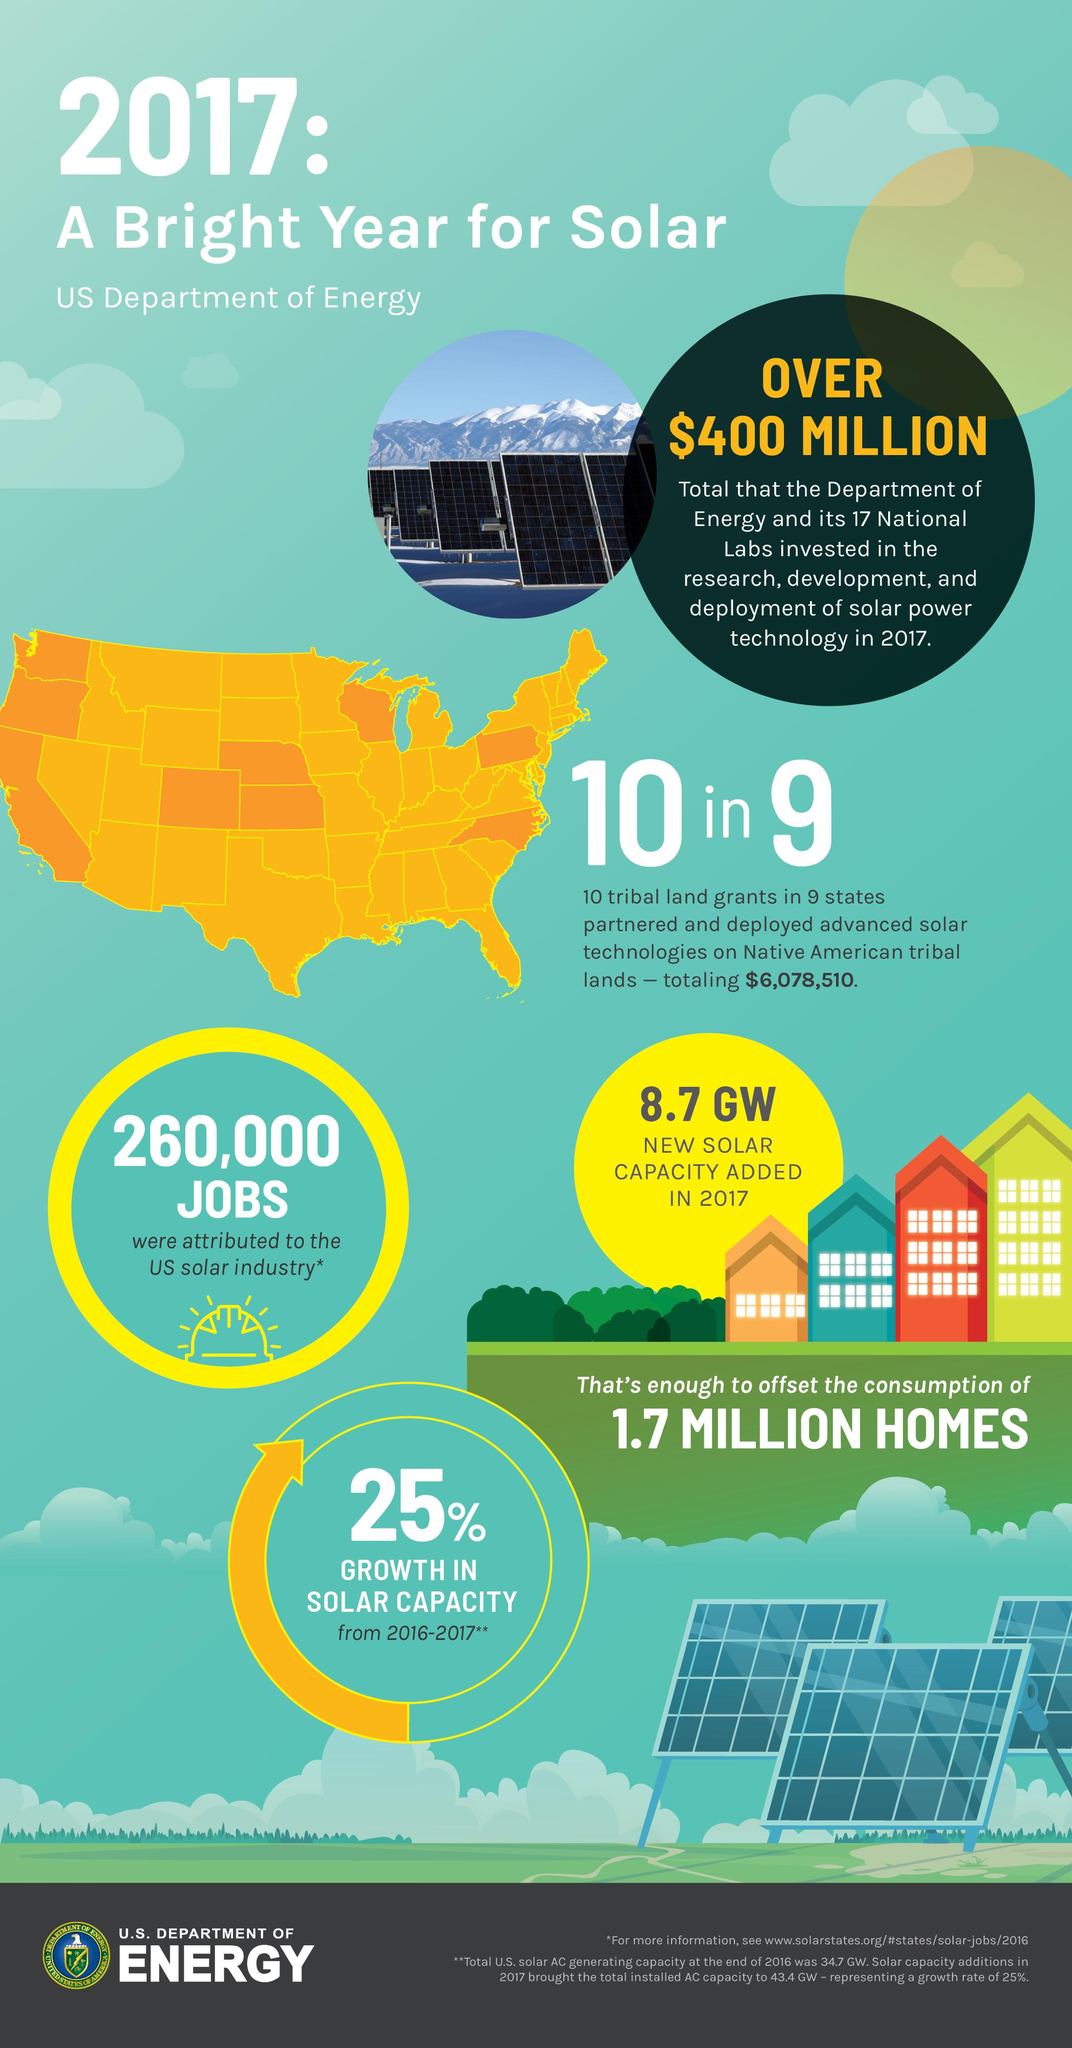Indicate a few pertinent items in this graphic. In 2017, the solar industry in the United States was attributed approximately 260,000 jobs. In 2017, the solar power generated to offset the consumption of 1.7 million homes in the United States was 8.7 gigawatts. In the United States, there was a 25% increase in solar capacity from 2016 to 2017, indicating a strong growth in the use of solar energy. 